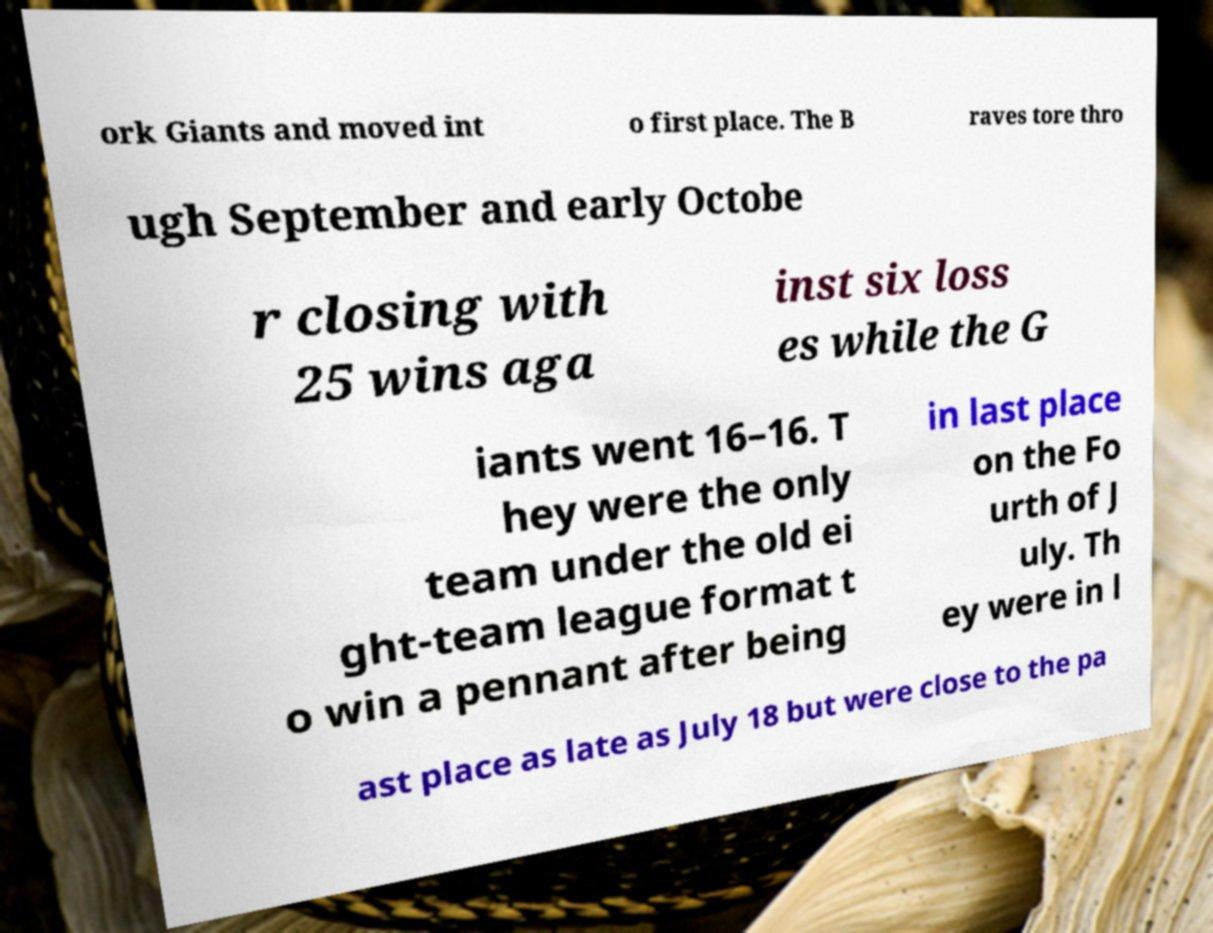Please identify and transcribe the text found in this image. ork Giants and moved int o first place. The B raves tore thro ugh September and early Octobe r closing with 25 wins aga inst six loss es while the G iants went 16–16. T hey were the only team under the old ei ght-team league format t o win a pennant after being in last place on the Fo urth of J uly. Th ey were in l ast place as late as July 18 but were close to the pa 